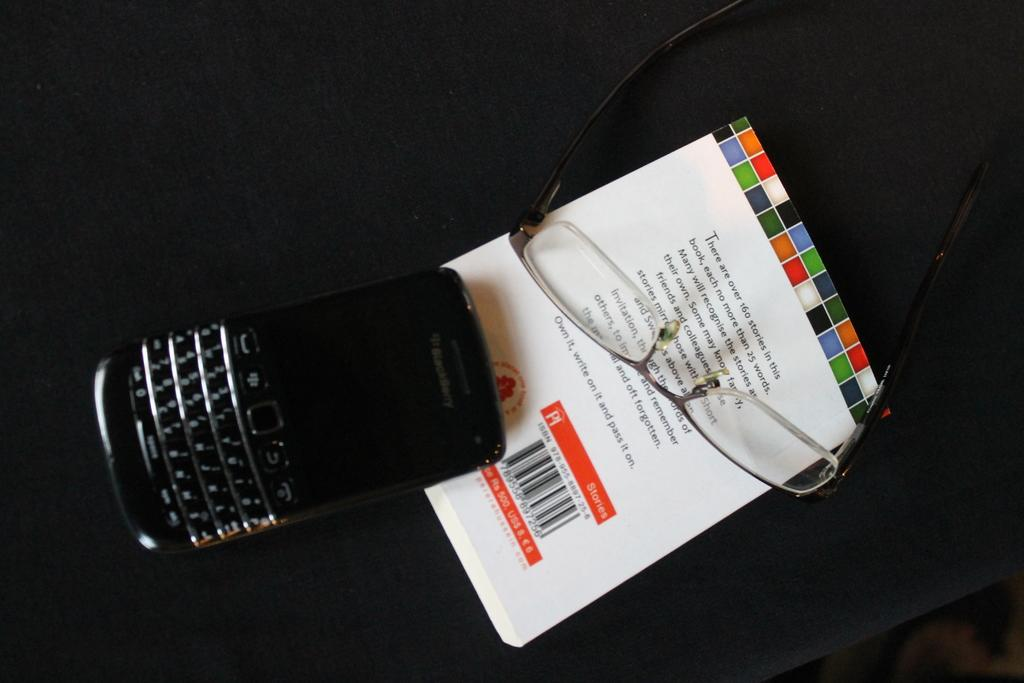Provide a one-sentence caption for the provided image. A BlackBerry mobile phone and a pair of glasses rest upon a book of short stories. 